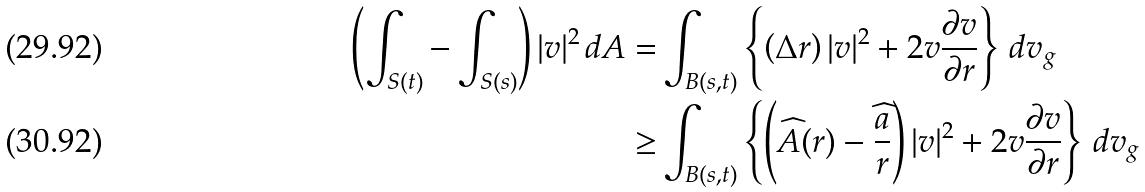<formula> <loc_0><loc_0><loc_500><loc_500>\left ( \int _ { S ( t ) } - \int _ { S ( s ) } \right ) | v | ^ { 2 } \, d A = & \int _ { B ( s , t ) } \left \{ \left ( \Delta r \right ) | v | ^ { 2 } + 2 v \frac { \partial v } { \partial r } \right \} \, d v _ { g } \\ \geq & \int _ { B ( s , t ) } \left \{ \left ( \widehat { A } ( r ) - \frac { \widehat { a } } { r } \right ) | v | ^ { 2 } + 2 v \frac { \partial v } { \partial r } \right \} \, d v _ { g }</formula> 